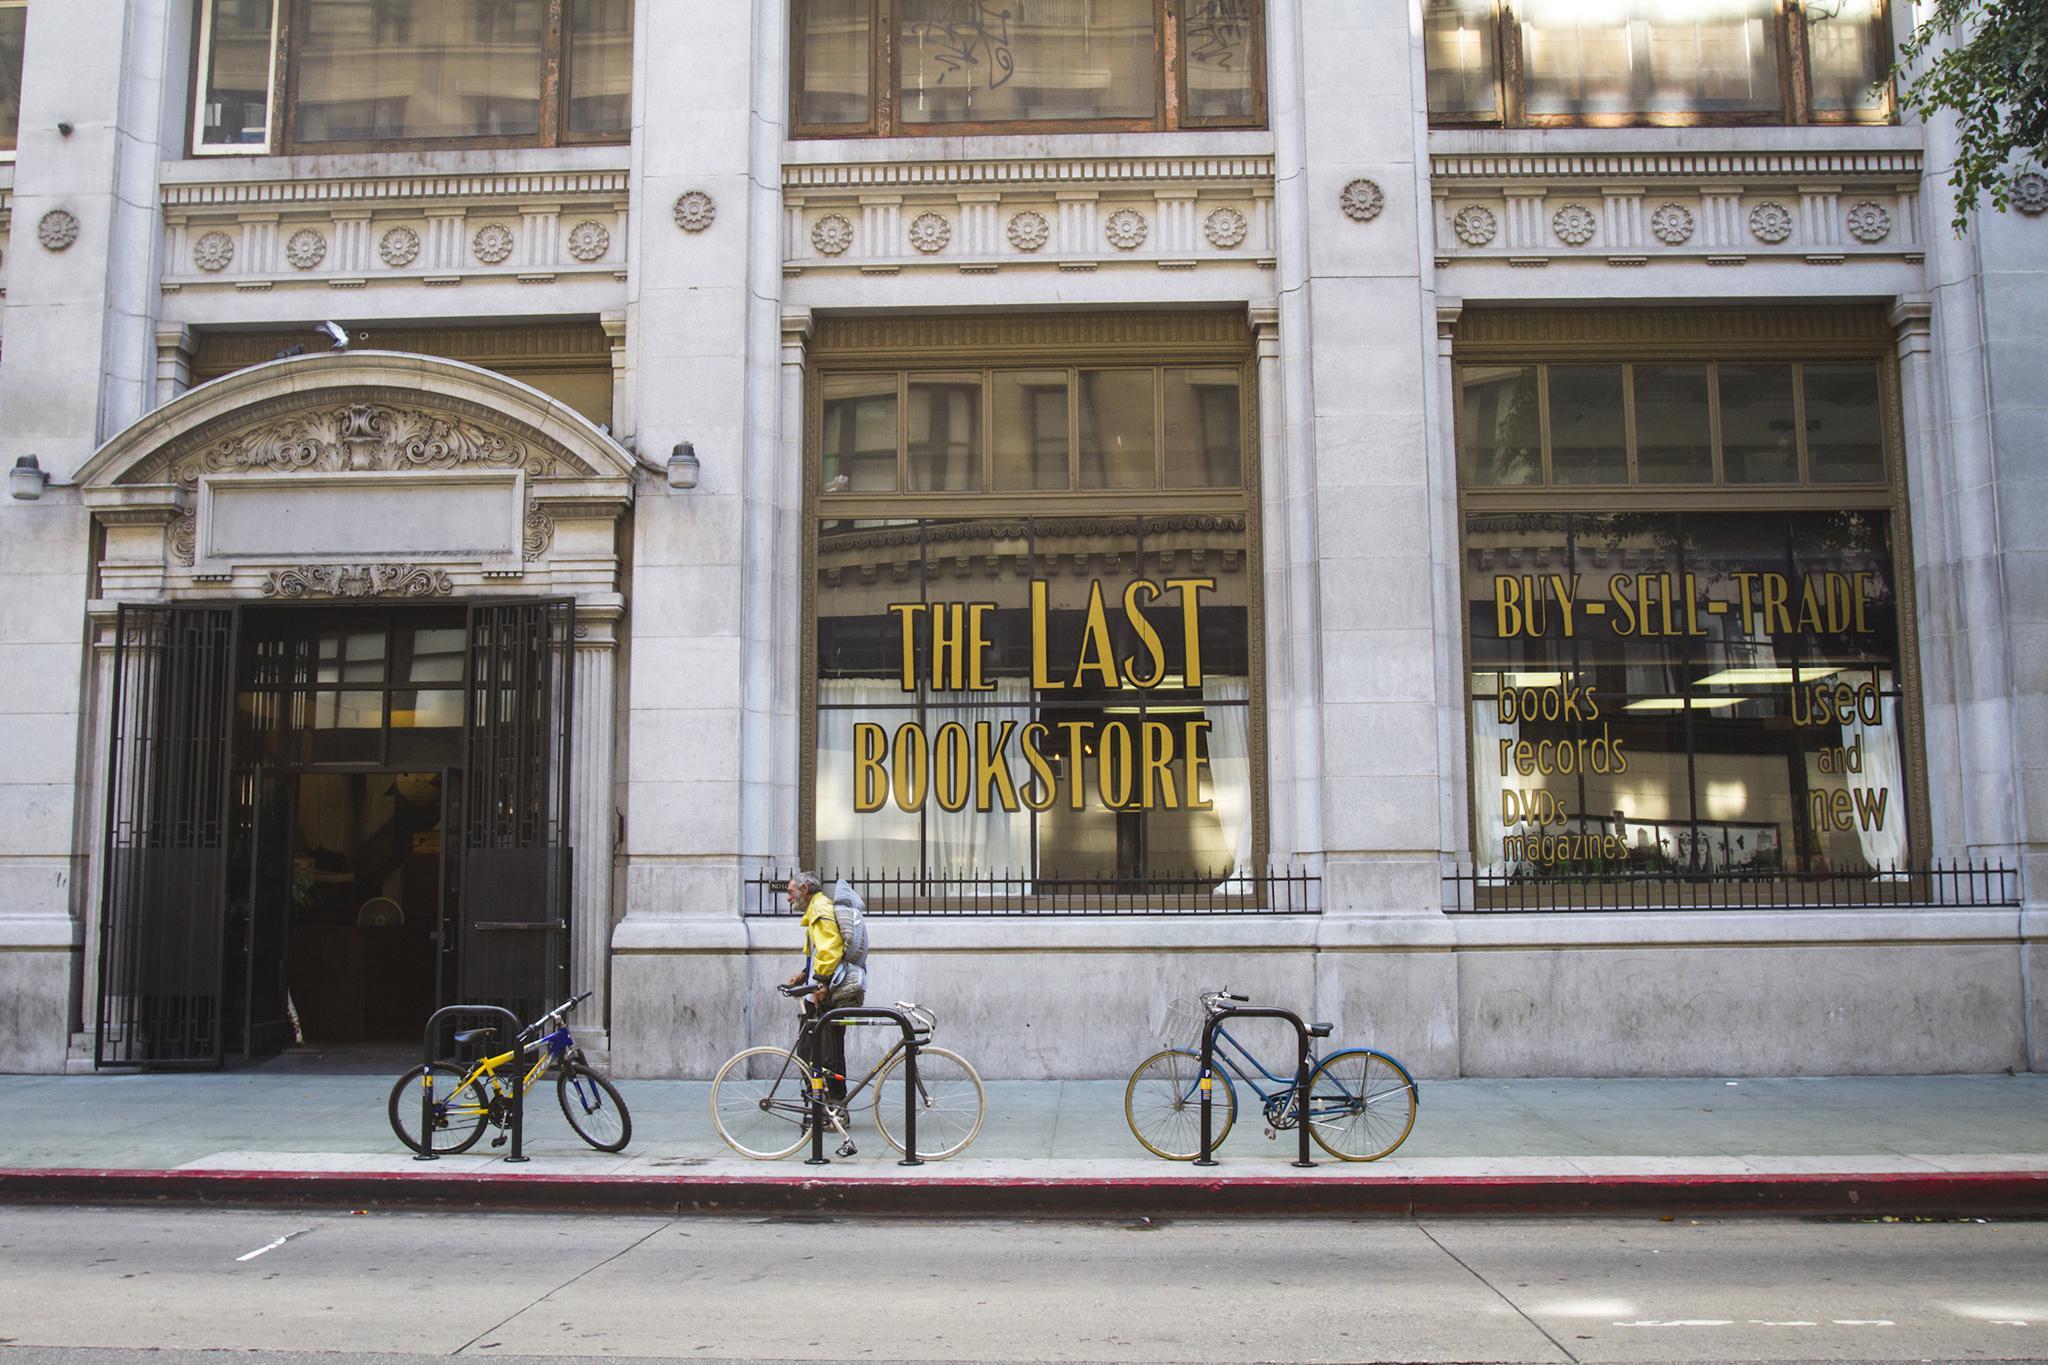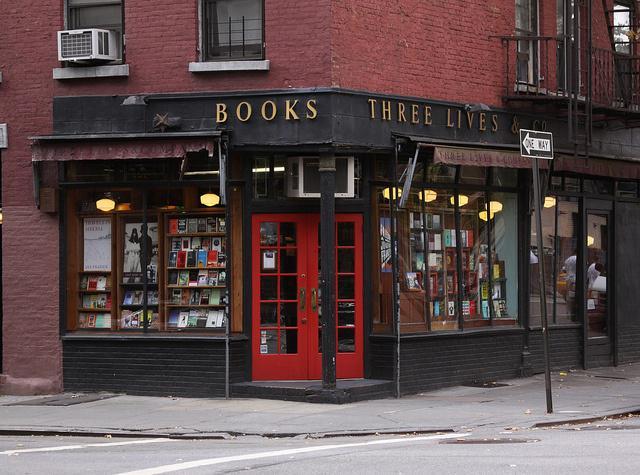The first image is the image on the left, the second image is the image on the right. Given the left and right images, does the statement "A single two-wheeled vehicle is parked in front of a shop with red double doors." hold true? Answer yes or no. No. The first image is the image on the left, the second image is the image on the right. Analyze the images presented: Is the assertion "The building on the right image has a closed red door while the building on the other side does not." valid? Answer yes or no. Yes. 